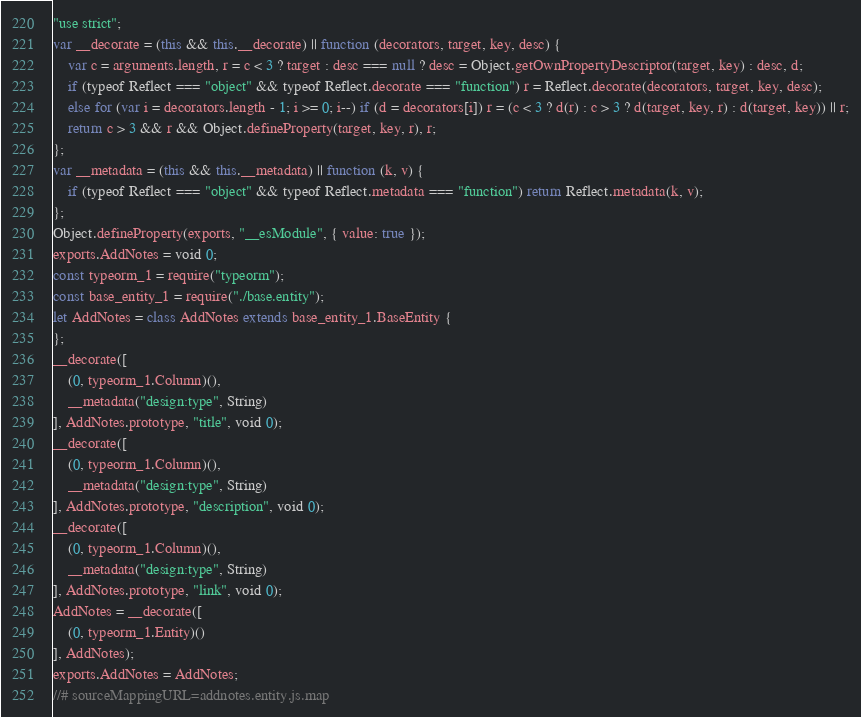Convert code to text. <code><loc_0><loc_0><loc_500><loc_500><_JavaScript_>"use strict";
var __decorate = (this && this.__decorate) || function (decorators, target, key, desc) {
    var c = arguments.length, r = c < 3 ? target : desc === null ? desc = Object.getOwnPropertyDescriptor(target, key) : desc, d;
    if (typeof Reflect === "object" && typeof Reflect.decorate === "function") r = Reflect.decorate(decorators, target, key, desc);
    else for (var i = decorators.length - 1; i >= 0; i--) if (d = decorators[i]) r = (c < 3 ? d(r) : c > 3 ? d(target, key, r) : d(target, key)) || r;
    return c > 3 && r && Object.defineProperty(target, key, r), r;
};
var __metadata = (this && this.__metadata) || function (k, v) {
    if (typeof Reflect === "object" && typeof Reflect.metadata === "function") return Reflect.metadata(k, v);
};
Object.defineProperty(exports, "__esModule", { value: true });
exports.AddNotes = void 0;
const typeorm_1 = require("typeorm");
const base_entity_1 = require("./base.entity");
let AddNotes = class AddNotes extends base_entity_1.BaseEntity {
};
__decorate([
    (0, typeorm_1.Column)(),
    __metadata("design:type", String)
], AddNotes.prototype, "title", void 0);
__decorate([
    (0, typeorm_1.Column)(),
    __metadata("design:type", String)
], AddNotes.prototype, "description", void 0);
__decorate([
    (0, typeorm_1.Column)(),
    __metadata("design:type", String)
], AddNotes.prototype, "link", void 0);
AddNotes = __decorate([
    (0, typeorm_1.Entity)()
], AddNotes);
exports.AddNotes = AddNotes;
//# sourceMappingURL=addnotes.entity.js.map</code> 